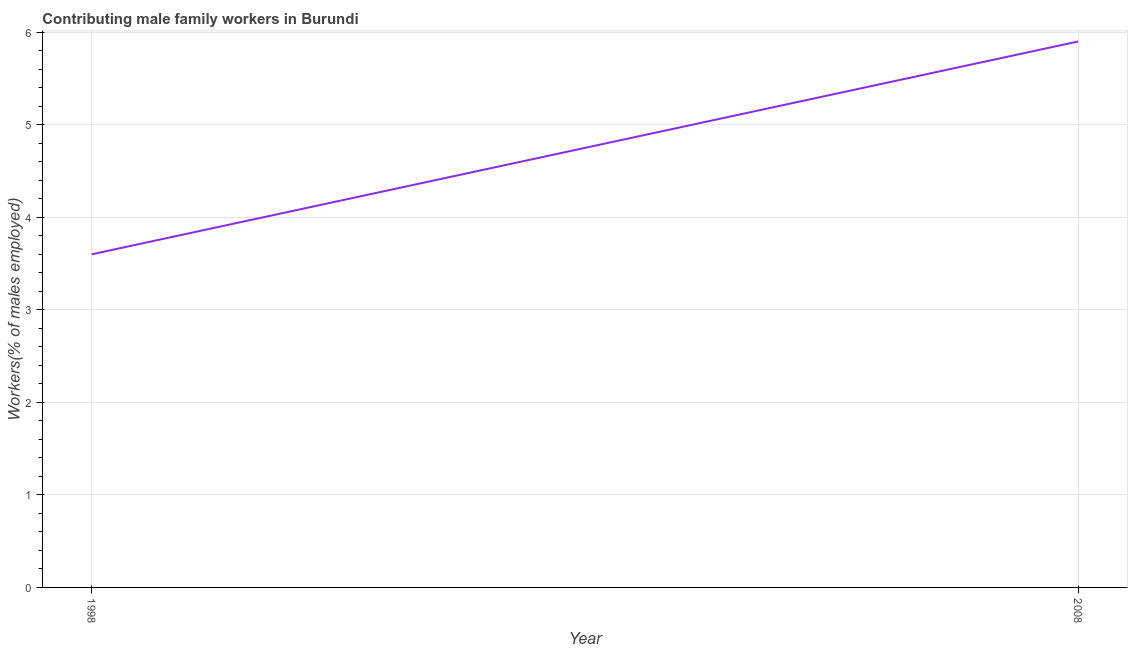What is the contributing male family workers in 2008?
Make the answer very short. 5.9. Across all years, what is the maximum contributing male family workers?
Ensure brevity in your answer.  5.9. Across all years, what is the minimum contributing male family workers?
Offer a terse response. 3.6. In which year was the contributing male family workers maximum?
Keep it short and to the point. 2008. In which year was the contributing male family workers minimum?
Ensure brevity in your answer.  1998. What is the sum of the contributing male family workers?
Provide a succinct answer. 9.5. What is the difference between the contributing male family workers in 1998 and 2008?
Your answer should be compact. -2.3. What is the average contributing male family workers per year?
Your answer should be compact. 4.75. What is the median contributing male family workers?
Make the answer very short. 4.75. Do a majority of the years between 1998 and 2008 (inclusive) have contributing male family workers greater than 5.8 %?
Offer a terse response. No. What is the ratio of the contributing male family workers in 1998 to that in 2008?
Provide a succinct answer. 0.61. How many lines are there?
Provide a short and direct response. 1. What is the difference between two consecutive major ticks on the Y-axis?
Your answer should be compact. 1. Are the values on the major ticks of Y-axis written in scientific E-notation?
Ensure brevity in your answer.  No. Does the graph contain grids?
Ensure brevity in your answer.  Yes. What is the title of the graph?
Your response must be concise. Contributing male family workers in Burundi. What is the label or title of the Y-axis?
Give a very brief answer. Workers(% of males employed). What is the Workers(% of males employed) of 1998?
Give a very brief answer. 3.6. What is the Workers(% of males employed) in 2008?
Provide a short and direct response. 5.9. What is the difference between the Workers(% of males employed) in 1998 and 2008?
Offer a very short reply. -2.3. What is the ratio of the Workers(% of males employed) in 1998 to that in 2008?
Your answer should be compact. 0.61. 